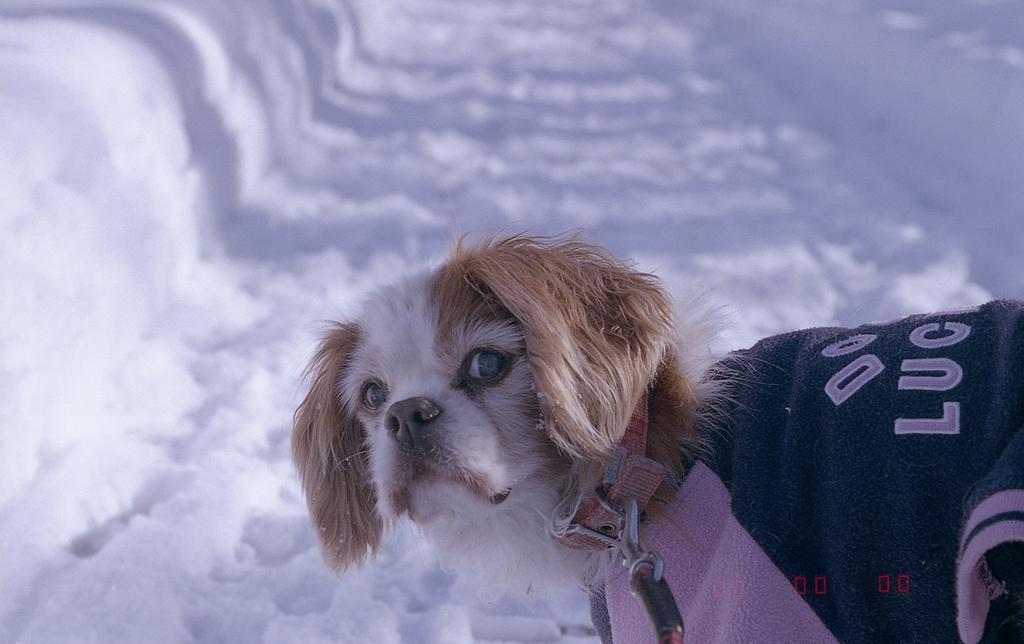Can you describe this image briefly? In this picture, we see a dog with brown and white fur is looking at the camera. It is wearing a jacket which is in black and pink color. It has a leash around its neck. In the background, we see the ice. 